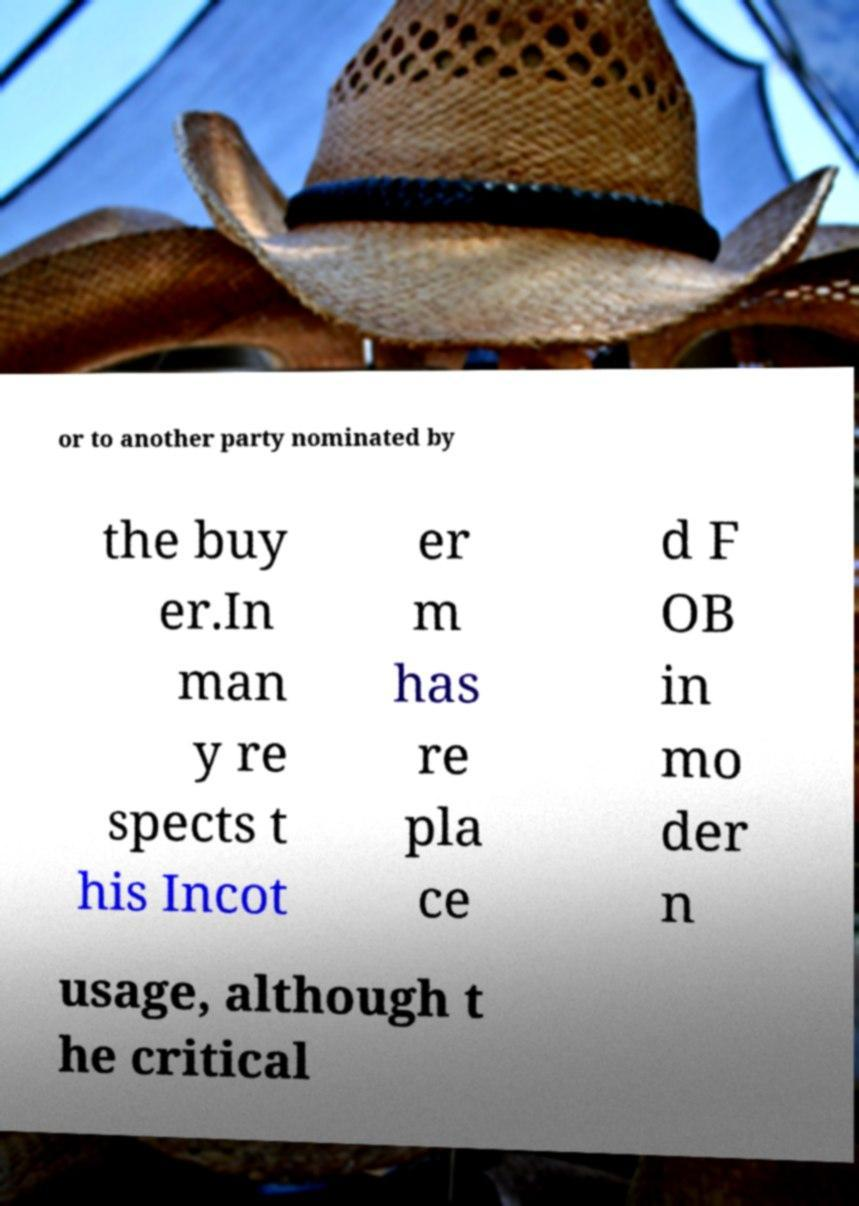Please identify and transcribe the text found in this image. or to another party nominated by the buy er.In man y re spects t his Incot er m has re pla ce d F OB in mo der n usage, although t he critical 